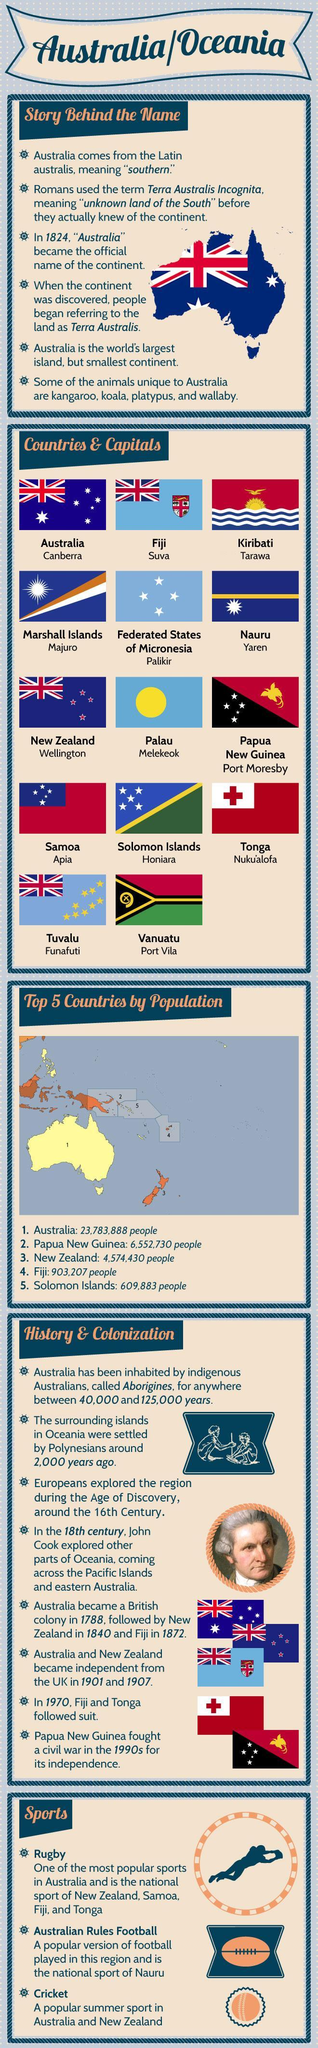What is the Capital of Fiji?
Answer the question with a short phrase. Suva When did New Zealand become independent? 1907 What is the Capital of Australia? Canberra What is the Capital of Tuvalu? Funafuti What is the Capital of Federated States of Micronesia? Palikir What is the Capital of Tonga? Nuku'alofa What is the total population of Fiji and Solomon islands? 1,513,090 What is the Capital of Palau? Melekeok When did Fiji become a British colony? 1872 What is the Capital of Samoa? Apia What is the Capital of Nauru? Yaren When did Fiji and Tonga become independent? 1970 